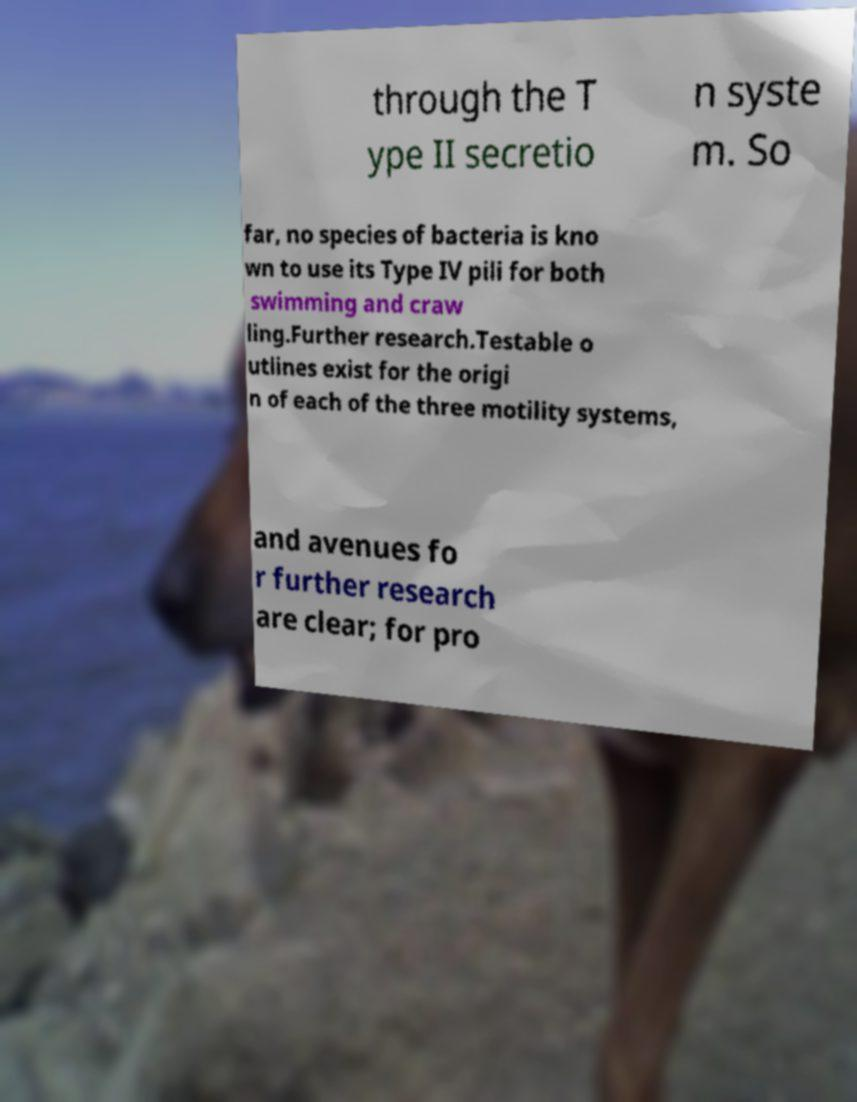There's text embedded in this image that I need extracted. Can you transcribe it verbatim? through the T ype II secretio n syste m. So far, no species of bacteria is kno wn to use its Type IV pili for both swimming and craw ling.Further research.Testable o utlines exist for the origi n of each of the three motility systems, and avenues fo r further research are clear; for pro 